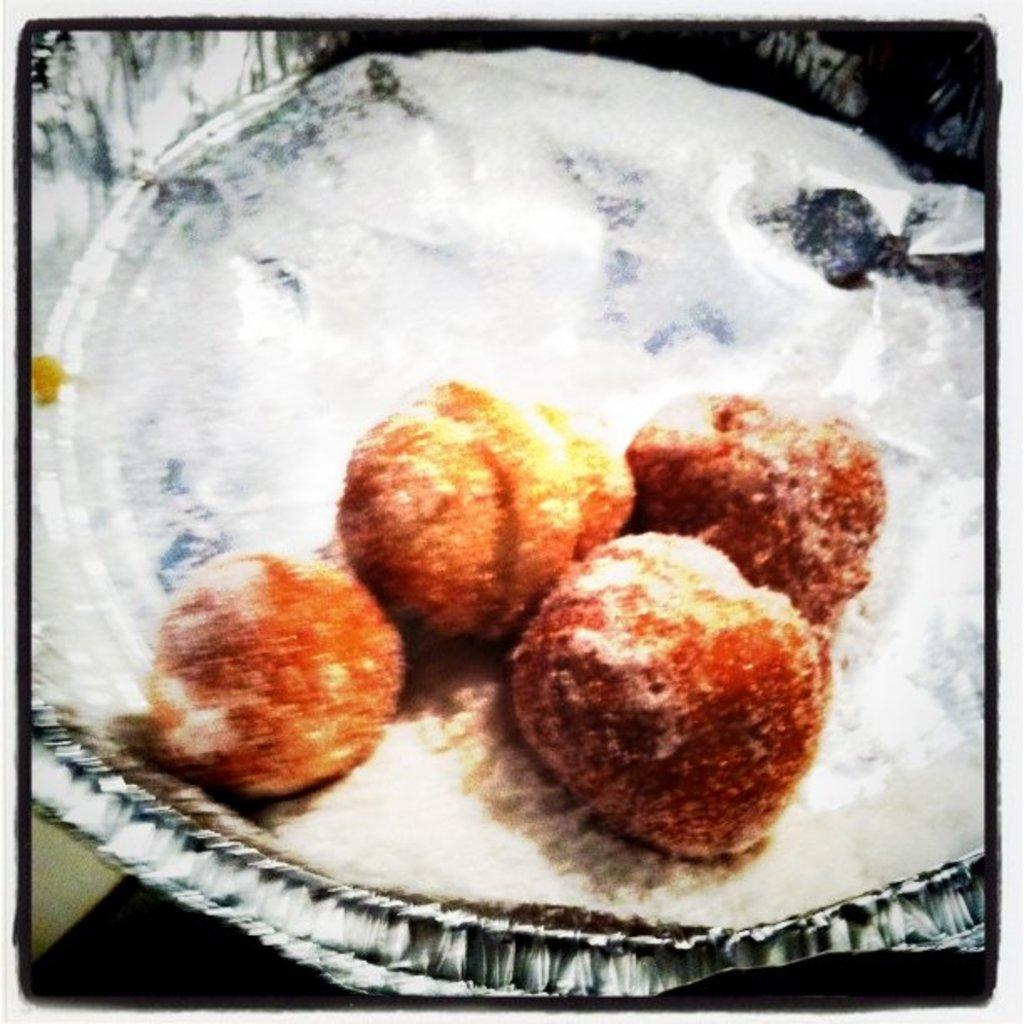What is on the paper plate in the image? There is a food item on the paper plate. Can you describe the paper plate in the image? The paper plate is the object on which the food item is placed. What type of reward is the paper plate offering in the image? The paper plate is not offering any reward in the image; it is simply holding a food item. Who is the partner of the paper plate in the image? The paper plate does not have a partner in the image; it is an inanimate object. 